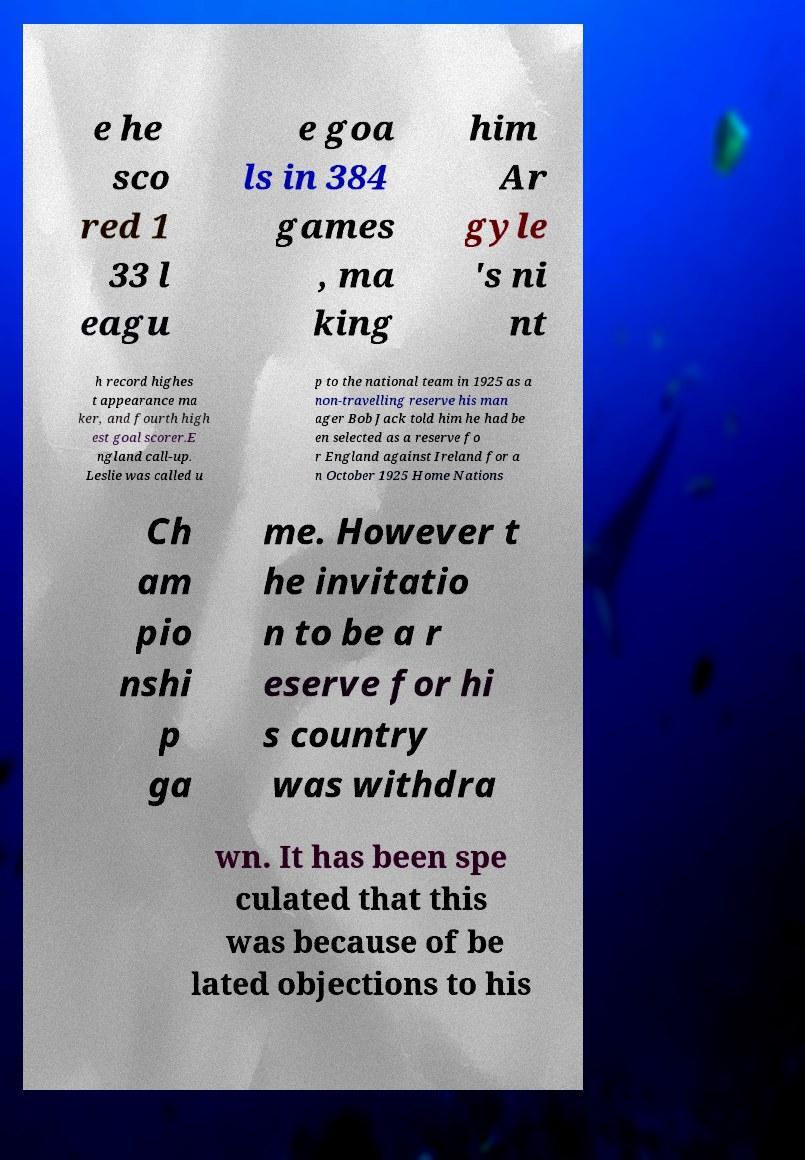Can you accurately transcribe the text from the provided image for me? e he sco red 1 33 l eagu e goa ls in 384 games , ma king him Ar gyle 's ni nt h record highes t appearance ma ker, and fourth high est goal scorer.E ngland call-up. Leslie was called u p to the national team in 1925 as a non-travelling reserve his man ager Bob Jack told him he had be en selected as a reserve fo r England against Ireland for a n October 1925 Home Nations Ch am pio nshi p ga me. However t he invitatio n to be a r eserve for hi s country was withdra wn. It has been spe culated that this was because of be lated objections to his 